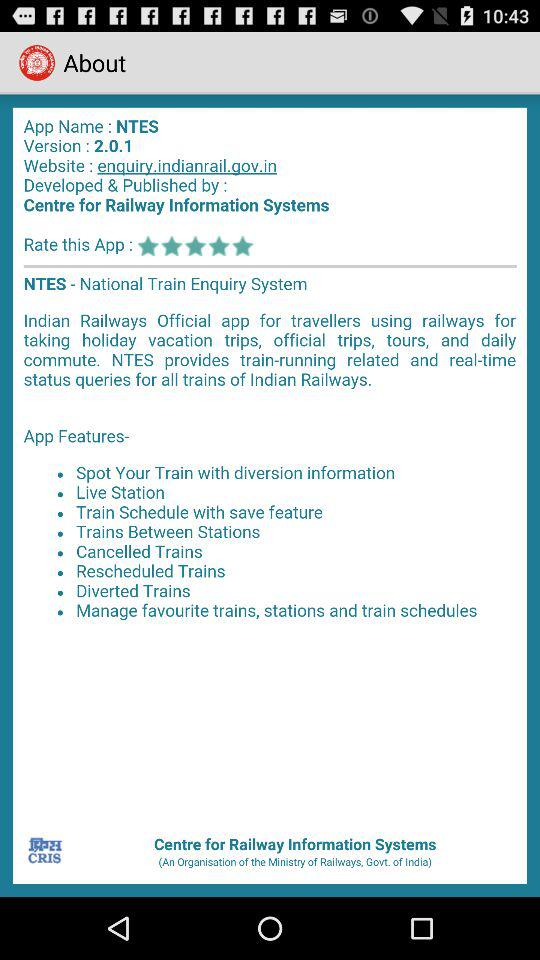What's the full form of NTES? The full form of NTES is the National Train Enquiry System. 